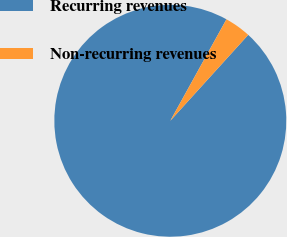<chart> <loc_0><loc_0><loc_500><loc_500><pie_chart><fcel>Recurring revenues<fcel>Non-recurring revenues<nl><fcel>96.32%<fcel>3.68%<nl></chart> 